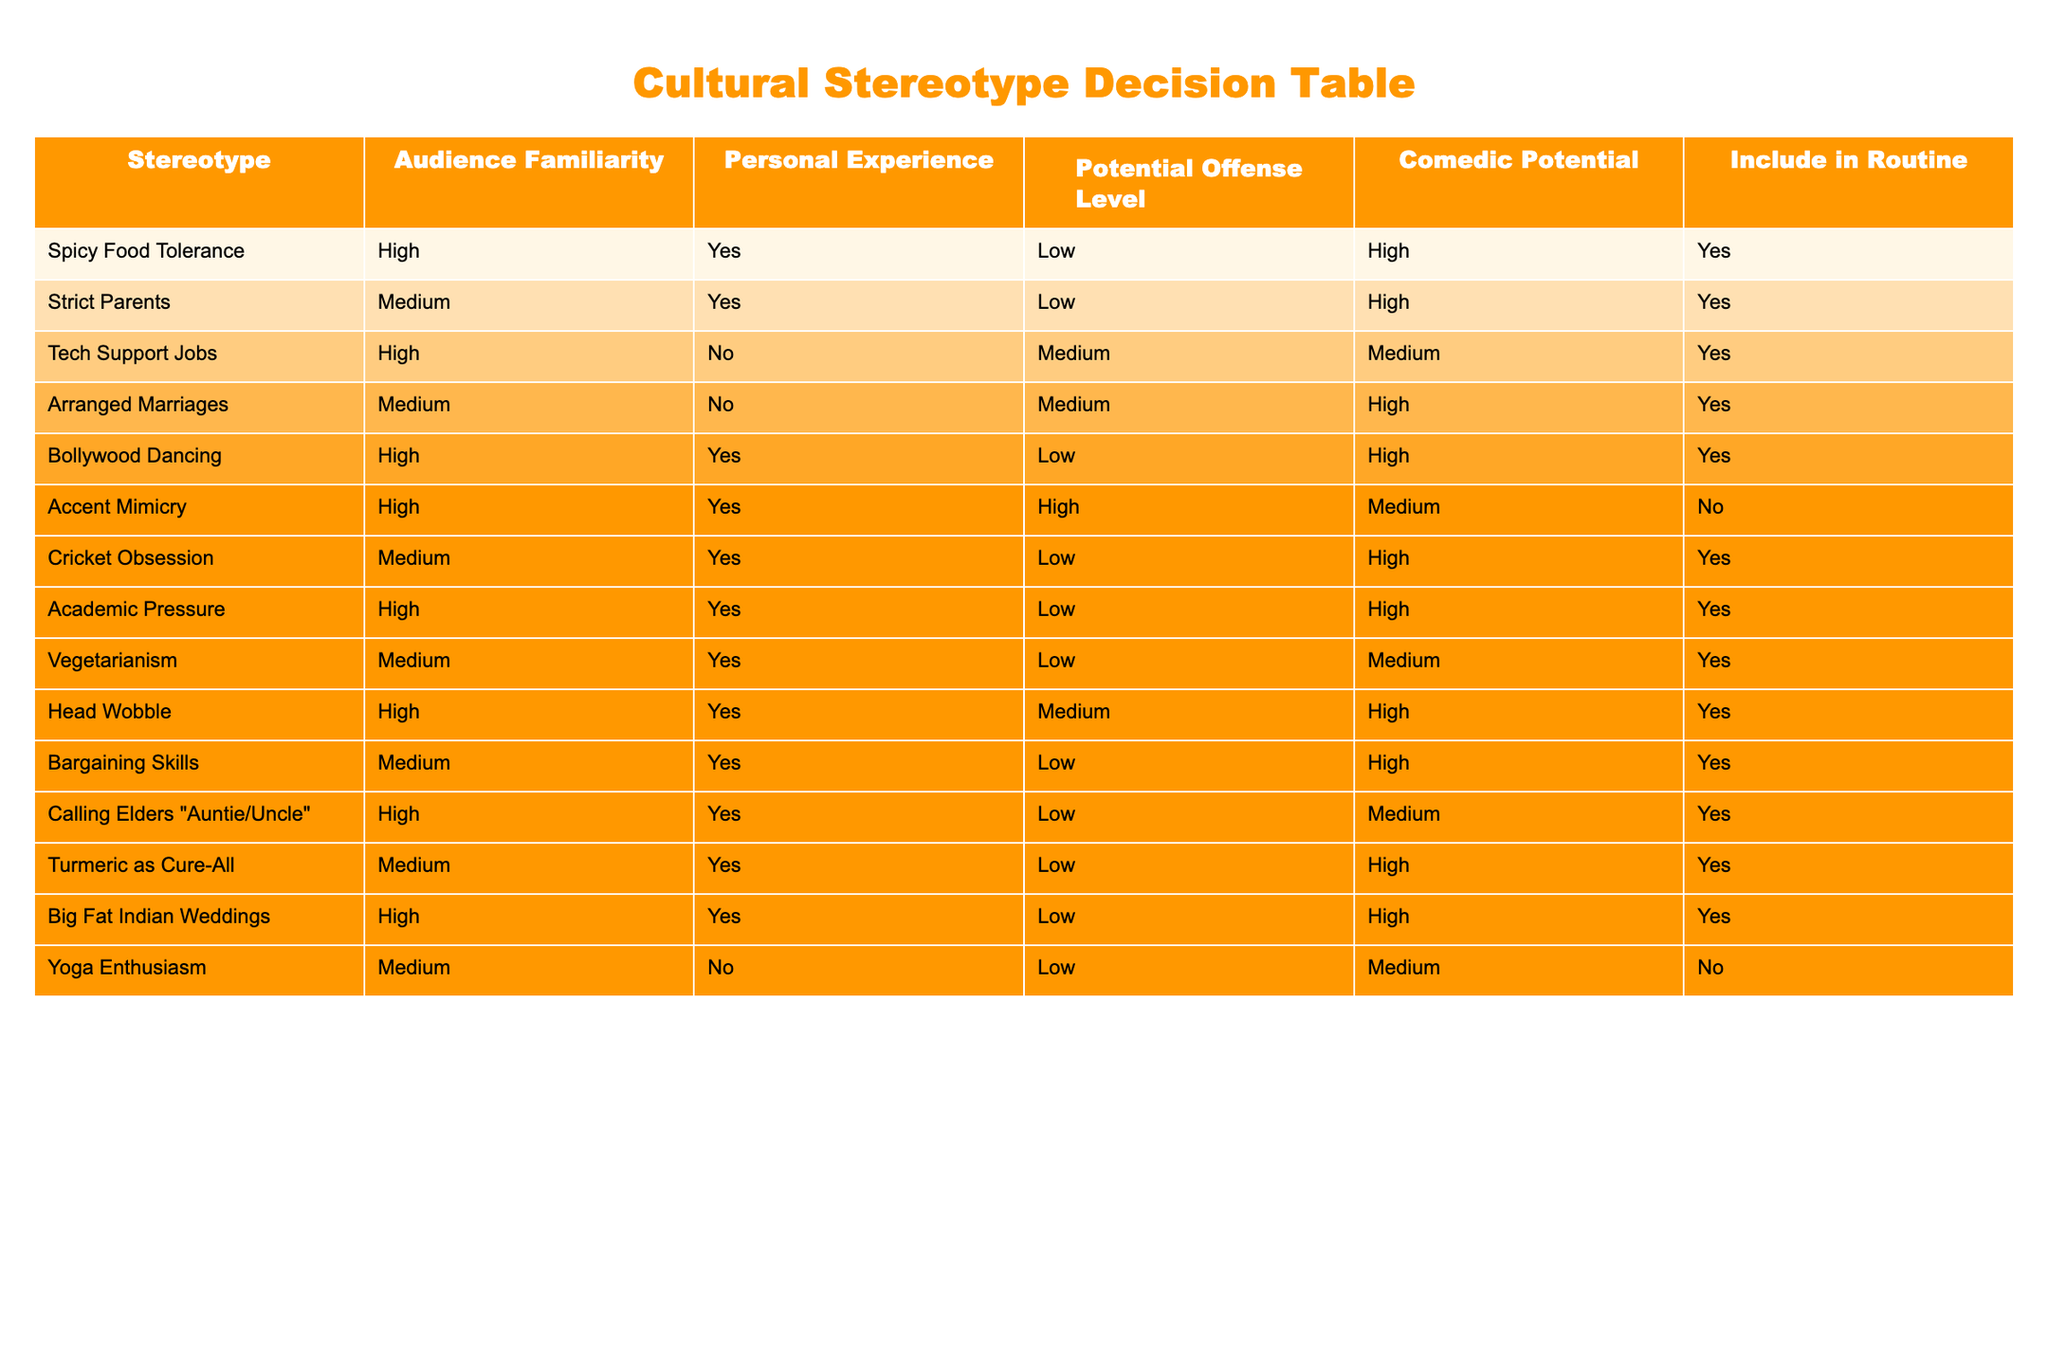What stereotype has the highest comedic potential? Looking at the "Comedic Potential" column, the highest value is "High". By scanning through the rows for stereotypes that have "High" listed as their comedic potential, we find several, including "Spicy Food Tolerance", "Strict Parents", "Bollywood Dancing", and "Cricket Obsession". However, among them, "Spicy Food Tolerance" is the first one listed
Answer: Spicy Food Tolerance Which stereotypes have a potential offense level classified as medium? We need to examine the "Potential Offense Level" column and identify all stereotypes that are marked as "Medium". Upon reviewing, the stereotypes "Tech Support Jobs", "Arranged Marriages", "Accent Mimicry", and "Head Wobble" have been classified as medium for potential offense
Answer: Tech Support Jobs, Arranged Marriages, Accent Mimicry, Head Wobble How many stereotypes include personal experience? To find this, we can inspect the "Personal Experience" column for the value "Yes". After going through all rows, we can count the number marked with "Yes". The following stereotypes have "Yes": "Spicy Food Tolerance", "Strict Parents", "Bollywood Dancing", "Cricket Obsession", "Academic Pressure", "Vegetarianism", "Bargaining Skills", "Calling Elders 'Auntie/Uncle'", "Turmeric as Cure-All", and "Big Fat Indian Weddings". This totals to ten instances
Answer: 10 Is there any stereotype that has both high audience familiarity and low potential offense? We need to evaluate both "Audience Familiarity" and "Potential Offense Level". Scanning down the "Audience Familiarity" column for "High" and the "Potential Offense Level" column for "Low", we find that “Spicy Food Tolerance”, “Bollywood Dancing”, and “Big Fat Indian Weddings” meet these criteria. Thus, we conclude that there are multiple stereotypes that fit this description
Answer: Yes What is the sum of the comedic potential values classified as low? First, we identify any stereotypes that have a "Comedic Potential" listed as "Low". These include "Tech Support Jobs", "Vegetarianism", and "Accent Mimicry". We assign numerical values: Low = 1. Then we sum these values: 1 (Tech Support Jobs) + 1 (Vegetarianism) + 0 (Accent Mimicry) = 2
Answer: 2 